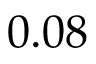Convert formula to latex. <formula><loc_0><loc_0><loc_500><loc_500>0 . 0 8</formula> 